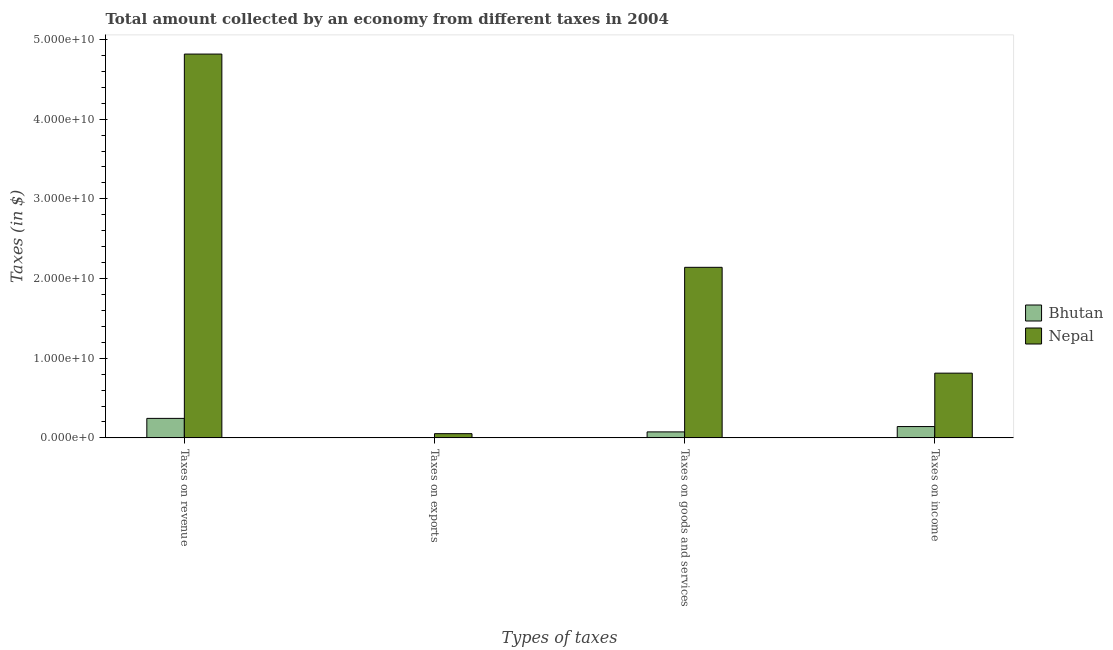Are the number of bars per tick equal to the number of legend labels?
Provide a succinct answer. Yes. Are the number of bars on each tick of the X-axis equal?
Provide a short and direct response. Yes. How many bars are there on the 1st tick from the right?
Offer a terse response. 2. What is the label of the 3rd group of bars from the left?
Provide a succinct answer. Taxes on goods and services. What is the amount collected as tax on revenue in Nepal?
Ensure brevity in your answer.  4.82e+1. Across all countries, what is the maximum amount collected as tax on exports?
Provide a succinct answer. 5.27e+08. Across all countries, what is the minimum amount collected as tax on exports?
Give a very brief answer. 4.91e+05. In which country was the amount collected as tax on goods maximum?
Give a very brief answer. Nepal. In which country was the amount collected as tax on revenue minimum?
Give a very brief answer. Bhutan. What is the total amount collected as tax on exports in the graph?
Give a very brief answer. 5.28e+08. What is the difference between the amount collected as tax on exports in Nepal and that in Bhutan?
Offer a very short reply. 5.27e+08. What is the difference between the amount collected as tax on income in Bhutan and the amount collected as tax on exports in Nepal?
Keep it short and to the point. 8.92e+08. What is the average amount collected as tax on exports per country?
Provide a short and direct response. 2.64e+08. What is the difference between the amount collected as tax on goods and amount collected as tax on income in Nepal?
Your answer should be very brief. 1.33e+1. What is the ratio of the amount collected as tax on revenue in Bhutan to that in Nepal?
Your answer should be very brief. 0.05. Is the amount collected as tax on income in Bhutan less than that in Nepal?
Your answer should be compact. Yes. Is the difference between the amount collected as tax on revenue in Bhutan and Nepal greater than the difference between the amount collected as tax on goods in Bhutan and Nepal?
Your answer should be compact. No. What is the difference between the highest and the second highest amount collected as tax on exports?
Ensure brevity in your answer.  5.27e+08. What is the difference between the highest and the lowest amount collected as tax on revenue?
Give a very brief answer. 4.57e+1. In how many countries, is the amount collected as tax on goods greater than the average amount collected as tax on goods taken over all countries?
Keep it short and to the point. 1. Is the sum of the amount collected as tax on revenue in Bhutan and Nepal greater than the maximum amount collected as tax on income across all countries?
Your response must be concise. Yes. What does the 2nd bar from the left in Taxes on revenue represents?
Offer a very short reply. Nepal. What does the 1st bar from the right in Taxes on revenue represents?
Offer a terse response. Nepal. Is it the case that in every country, the sum of the amount collected as tax on revenue and amount collected as tax on exports is greater than the amount collected as tax on goods?
Provide a short and direct response. Yes. Are all the bars in the graph horizontal?
Provide a short and direct response. No. Are the values on the major ticks of Y-axis written in scientific E-notation?
Your response must be concise. Yes. Does the graph contain any zero values?
Ensure brevity in your answer.  No. Does the graph contain grids?
Your response must be concise. No. Where does the legend appear in the graph?
Give a very brief answer. Center right. How many legend labels are there?
Give a very brief answer. 2. How are the legend labels stacked?
Offer a terse response. Vertical. What is the title of the graph?
Make the answer very short. Total amount collected by an economy from different taxes in 2004. What is the label or title of the X-axis?
Provide a succinct answer. Types of taxes. What is the label or title of the Y-axis?
Your answer should be very brief. Taxes (in $). What is the Taxes (in $) of Bhutan in Taxes on revenue?
Offer a very short reply. 2.45e+09. What is the Taxes (in $) in Nepal in Taxes on revenue?
Make the answer very short. 4.82e+1. What is the Taxes (in $) in Bhutan in Taxes on exports?
Your answer should be compact. 4.91e+05. What is the Taxes (in $) of Nepal in Taxes on exports?
Keep it short and to the point. 5.27e+08. What is the Taxes (in $) of Bhutan in Taxes on goods and services?
Make the answer very short. 7.50e+08. What is the Taxes (in $) in Nepal in Taxes on goods and services?
Keep it short and to the point. 2.14e+1. What is the Taxes (in $) of Bhutan in Taxes on income?
Ensure brevity in your answer.  1.42e+09. What is the Taxes (in $) of Nepal in Taxes on income?
Your answer should be very brief. 8.12e+09. Across all Types of taxes, what is the maximum Taxes (in $) of Bhutan?
Keep it short and to the point. 2.45e+09. Across all Types of taxes, what is the maximum Taxes (in $) in Nepal?
Your answer should be compact. 4.82e+1. Across all Types of taxes, what is the minimum Taxes (in $) of Bhutan?
Your response must be concise. 4.91e+05. Across all Types of taxes, what is the minimum Taxes (in $) in Nepal?
Your answer should be very brief. 5.27e+08. What is the total Taxes (in $) in Bhutan in the graph?
Your response must be concise. 4.62e+09. What is the total Taxes (in $) of Nepal in the graph?
Ensure brevity in your answer.  7.82e+1. What is the difference between the Taxes (in $) of Bhutan in Taxes on revenue and that in Taxes on exports?
Ensure brevity in your answer.  2.45e+09. What is the difference between the Taxes (in $) in Nepal in Taxes on revenue and that in Taxes on exports?
Give a very brief answer. 4.76e+1. What is the difference between the Taxes (in $) in Bhutan in Taxes on revenue and that in Taxes on goods and services?
Offer a terse response. 1.70e+09. What is the difference between the Taxes (in $) in Nepal in Taxes on revenue and that in Taxes on goods and services?
Provide a succinct answer. 2.68e+1. What is the difference between the Taxes (in $) in Bhutan in Taxes on revenue and that in Taxes on income?
Provide a short and direct response. 1.03e+09. What is the difference between the Taxes (in $) in Nepal in Taxes on revenue and that in Taxes on income?
Offer a very short reply. 4.00e+1. What is the difference between the Taxes (in $) in Bhutan in Taxes on exports and that in Taxes on goods and services?
Provide a succinct answer. -7.50e+08. What is the difference between the Taxes (in $) in Nepal in Taxes on exports and that in Taxes on goods and services?
Keep it short and to the point. -2.09e+1. What is the difference between the Taxes (in $) in Bhutan in Taxes on exports and that in Taxes on income?
Your answer should be very brief. -1.42e+09. What is the difference between the Taxes (in $) of Nepal in Taxes on exports and that in Taxes on income?
Keep it short and to the point. -7.60e+09. What is the difference between the Taxes (in $) in Bhutan in Taxes on goods and services and that in Taxes on income?
Give a very brief answer. -6.69e+08. What is the difference between the Taxes (in $) in Nepal in Taxes on goods and services and that in Taxes on income?
Your answer should be compact. 1.33e+1. What is the difference between the Taxes (in $) in Bhutan in Taxes on revenue and the Taxes (in $) in Nepal in Taxes on exports?
Give a very brief answer. 1.92e+09. What is the difference between the Taxes (in $) of Bhutan in Taxes on revenue and the Taxes (in $) of Nepal in Taxes on goods and services?
Give a very brief answer. -1.90e+1. What is the difference between the Taxes (in $) of Bhutan in Taxes on revenue and the Taxes (in $) of Nepal in Taxes on income?
Offer a terse response. -5.68e+09. What is the difference between the Taxes (in $) of Bhutan in Taxes on exports and the Taxes (in $) of Nepal in Taxes on goods and services?
Offer a very short reply. -2.14e+1. What is the difference between the Taxes (in $) in Bhutan in Taxes on exports and the Taxes (in $) in Nepal in Taxes on income?
Your answer should be very brief. -8.12e+09. What is the difference between the Taxes (in $) in Bhutan in Taxes on goods and services and the Taxes (in $) in Nepal in Taxes on income?
Make the answer very short. -7.37e+09. What is the average Taxes (in $) of Bhutan per Types of taxes?
Your answer should be very brief. 1.15e+09. What is the average Taxes (in $) of Nepal per Types of taxes?
Offer a terse response. 1.96e+1. What is the difference between the Taxes (in $) of Bhutan and Taxes (in $) of Nepal in Taxes on revenue?
Your answer should be compact. -4.57e+1. What is the difference between the Taxes (in $) in Bhutan and Taxes (in $) in Nepal in Taxes on exports?
Offer a very short reply. -5.27e+08. What is the difference between the Taxes (in $) of Bhutan and Taxes (in $) of Nepal in Taxes on goods and services?
Provide a short and direct response. -2.07e+1. What is the difference between the Taxes (in $) of Bhutan and Taxes (in $) of Nepal in Taxes on income?
Keep it short and to the point. -6.70e+09. What is the ratio of the Taxes (in $) in Bhutan in Taxes on revenue to that in Taxes on exports?
Make the answer very short. 4982.89. What is the ratio of the Taxes (in $) of Nepal in Taxes on revenue to that in Taxes on exports?
Give a very brief answer. 91.39. What is the ratio of the Taxes (in $) of Bhutan in Taxes on revenue to that in Taxes on goods and services?
Your answer should be compact. 3.26. What is the ratio of the Taxes (in $) in Nepal in Taxes on revenue to that in Taxes on goods and services?
Your answer should be very brief. 2.25. What is the ratio of the Taxes (in $) in Bhutan in Taxes on revenue to that in Taxes on income?
Make the answer very short. 1.72. What is the ratio of the Taxes (in $) in Nepal in Taxes on revenue to that in Taxes on income?
Offer a terse response. 5.93. What is the ratio of the Taxes (in $) in Bhutan in Taxes on exports to that in Taxes on goods and services?
Give a very brief answer. 0. What is the ratio of the Taxes (in $) in Nepal in Taxes on exports to that in Taxes on goods and services?
Keep it short and to the point. 0.02. What is the ratio of the Taxes (in $) in Bhutan in Taxes on exports to that in Taxes on income?
Your answer should be very brief. 0. What is the ratio of the Taxes (in $) in Nepal in Taxes on exports to that in Taxes on income?
Ensure brevity in your answer.  0.06. What is the ratio of the Taxes (in $) of Bhutan in Taxes on goods and services to that in Taxes on income?
Ensure brevity in your answer.  0.53. What is the ratio of the Taxes (in $) in Nepal in Taxes on goods and services to that in Taxes on income?
Keep it short and to the point. 2.64. What is the difference between the highest and the second highest Taxes (in $) in Bhutan?
Keep it short and to the point. 1.03e+09. What is the difference between the highest and the second highest Taxes (in $) of Nepal?
Offer a terse response. 2.68e+1. What is the difference between the highest and the lowest Taxes (in $) of Bhutan?
Provide a succinct answer. 2.45e+09. What is the difference between the highest and the lowest Taxes (in $) in Nepal?
Your answer should be very brief. 4.76e+1. 